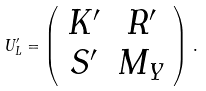Convert formula to latex. <formula><loc_0><loc_0><loc_500><loc_500>U _ { L } ^ { \prime } = \left ( \begin{array} { c c } { { K ^ { \prime } } } & { { R ^ { \prime } } } \\ { { S ^ { \prime } } } & { { M _ { Y } } } \end{array} \right ) \, .</formula> 